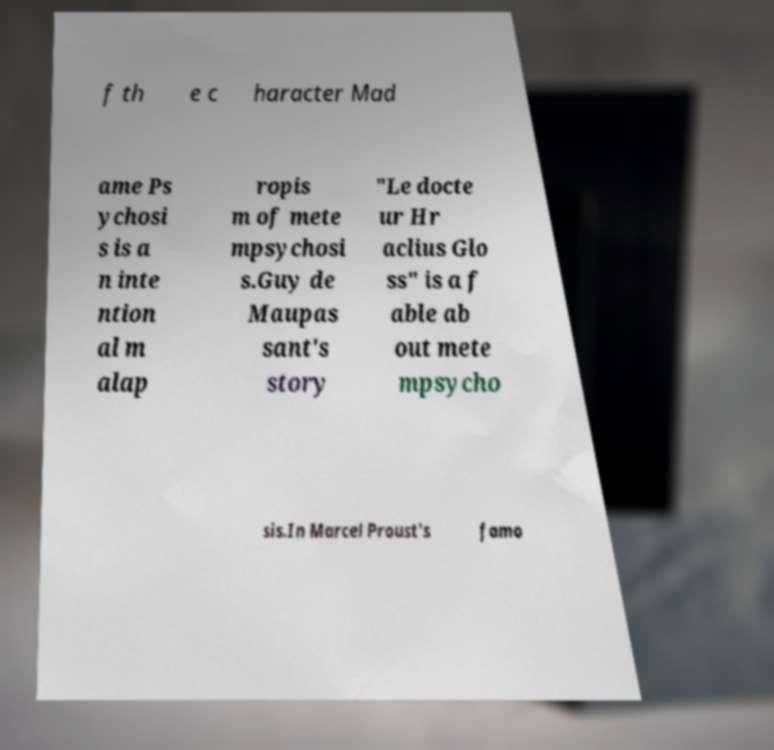Please read and relay the text visible in this image. What does it say? f th e c haracter Mad ame Ps ychosi s is a n inte ntion al m alap ropis m of mete mpsychosi s.Guy de Maupas sant's story "Le docte ur Hr aclius Glo ss" is a f able ab out mete mpsycho sis.In Marcel Proust's famo 